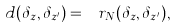<formula> <loc_0><loc_0><loc_500><loc_500>d ( \delta _ { z } , \delta _ { z ^ { \prime } } ) = \ r _ { N } ( \delta _ { z } , \delta _ { z ^ { \prime } } ) ,</formula> 